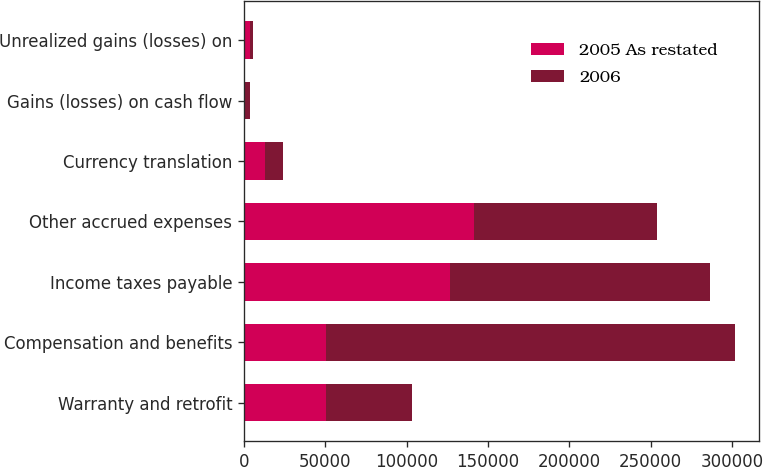<chart> <loc_0><loc_0><loc_500><loc_500><stacked_bar_chart><ecel><fcel>Warranty and retrofit<fcel>Compensation and benefits<fcel>Income taxes payable<fcel>Other accrued expenses<fcel>Currency translation<fcel>Gains (losses) on cash flow<fcel>Unrealized gains (losses) on<nl><fcel>2005 As restated<fcel>50604<fcel>50604<fcel>126750<fcel>141435<fcel>12671<fcel>80<fcel>3683<nl><fcel>2006<fcel>52845<fcel>251060<fcel>159928<fcel>112230<fcel>11374<fcel>3311<fcel>1588<nl></chart> 